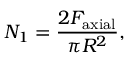Convert formula to latex. <formula><loc_0><loc_0><loc_500><loc_500>N _ { 1 } = \frac { 2 F _ { a x i a l } } { \pi R ^ { 2 } } ,</formula> 